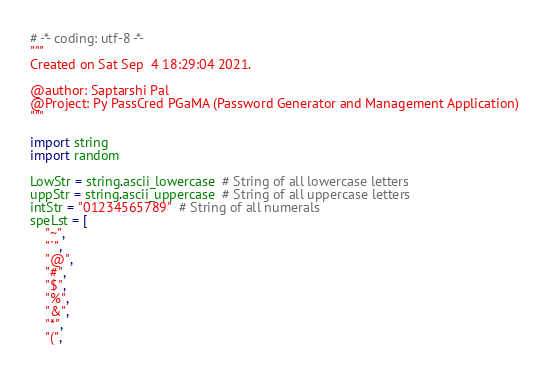<code> <loc_0><loc_0><loc_500><loc_500><_Python_># -*- coding: utf-8 -*-
"""
Created on Sat Sep  4 18:29:04 2021.

@author: Saptarshi Pal
@Project: Py PassCred PGaMA (Password Generator and Management Application)
"""

import string
import random

LowStr = string.ascii_lowercase  # String of all lowercase letters
uppStr = string.ascii_uppercase  # String of all uppercase letters
intStr = "01234565789"  # String of all numerals
speLst = [
    "~",
    "`",
    "@",
    "#",
    "$",
    "%",
    "&",
    "*",
    "(",</code> 